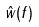<formula> <loc_0><loc_0><loc_500><loc_500>\hat { w } ( f )</formula> 